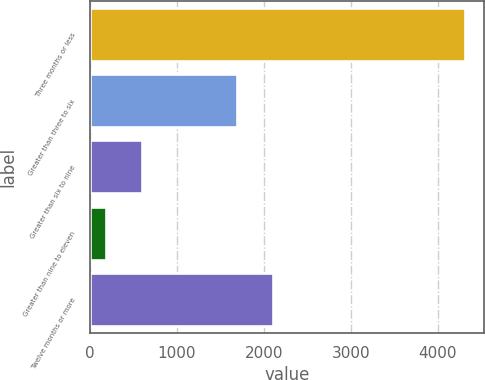<chart> <loc_0><loc_0><loc_500><loc_500><bar_chart><fcel>Three months or less<fcel>Greater than three to six<fcel>Greater than six to nine<fcel>Greater than nine to eleven<fcel>Twelve months or more<nl><fcel>4315<fcel>1694<fcel>601<fcel>188<fcel>2106.7<nl></chart> 